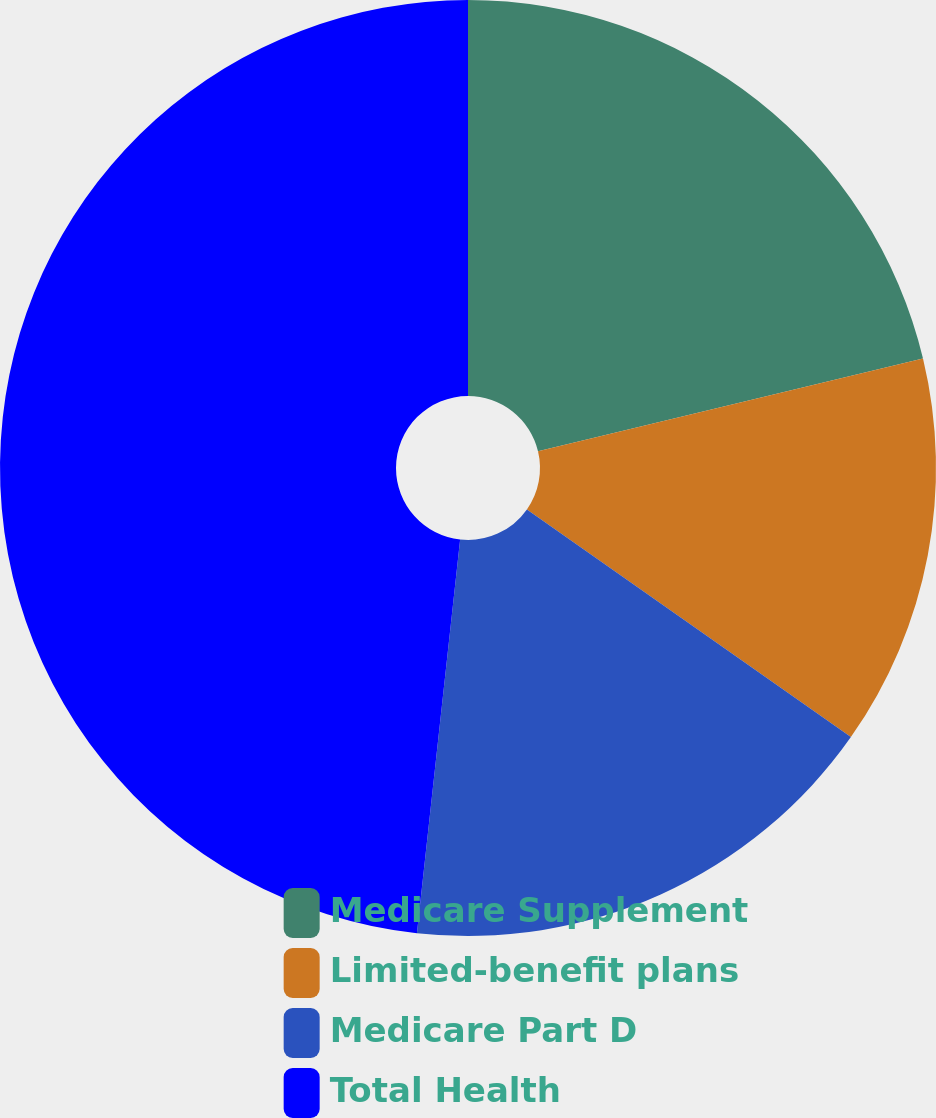Convert chart to OTSL. <chart><loc_0><loc_0><loc_500><loc_500><pie_chart><fcel>Medicare Supplement<fcel>Limited-benefit plans<fcel>Medicare Part D<fcel>Total Health<nl><fcel>21.24%<fcel>13.51%<fcel>16.99%<fcel>48.26%<nl></chart> 